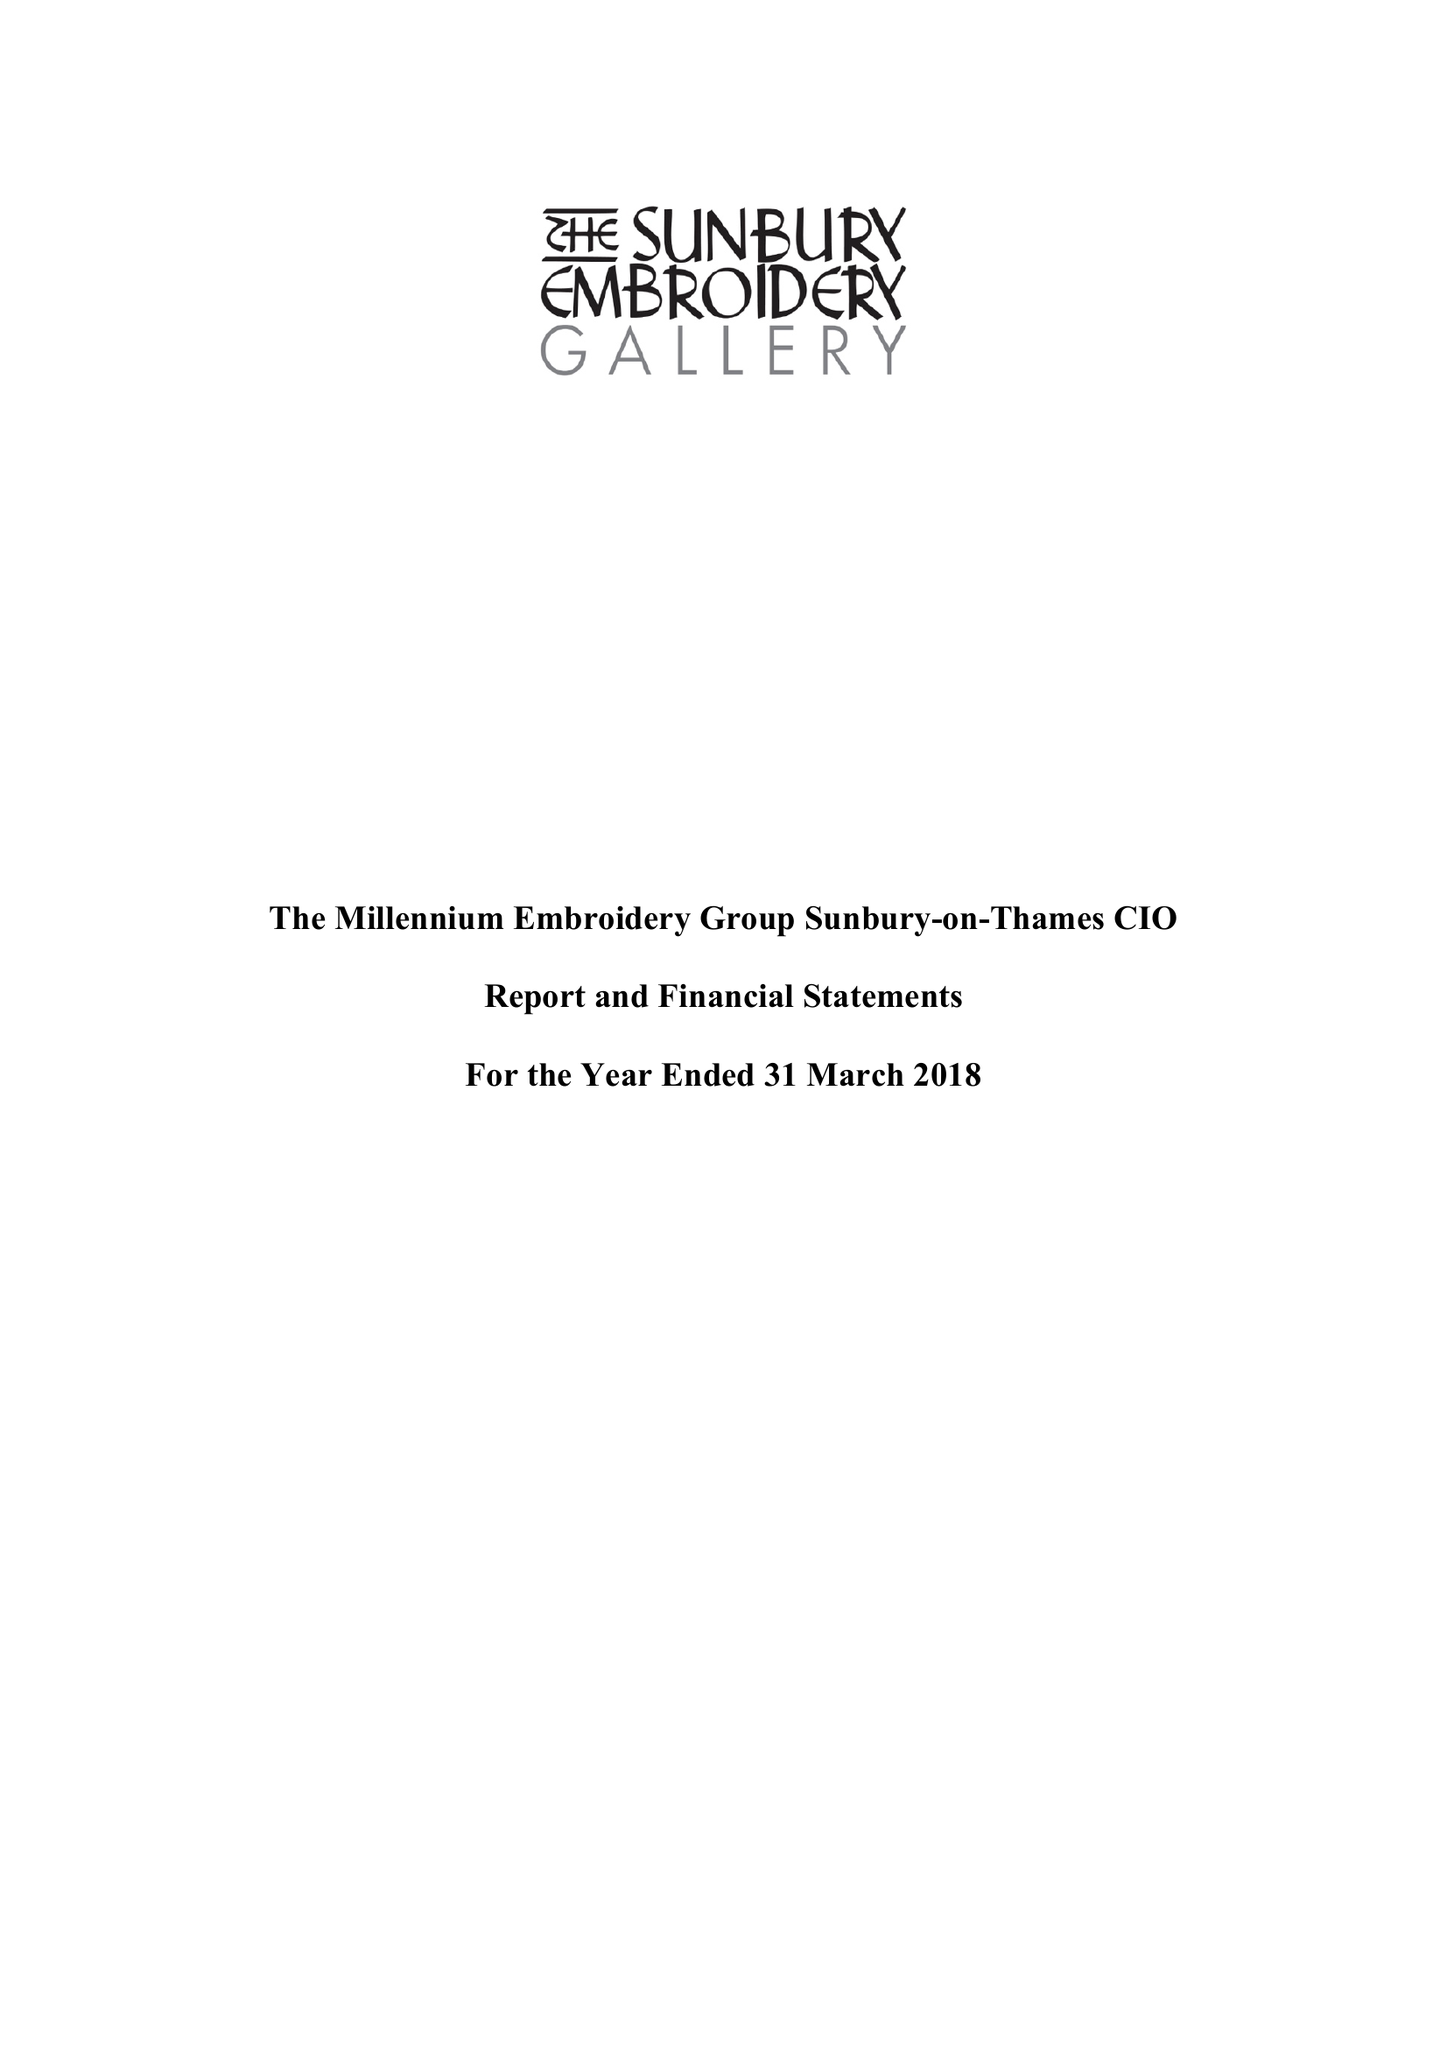What is the value for the report_date?
Answer the question using a single word or phrase. 2018-03-31 